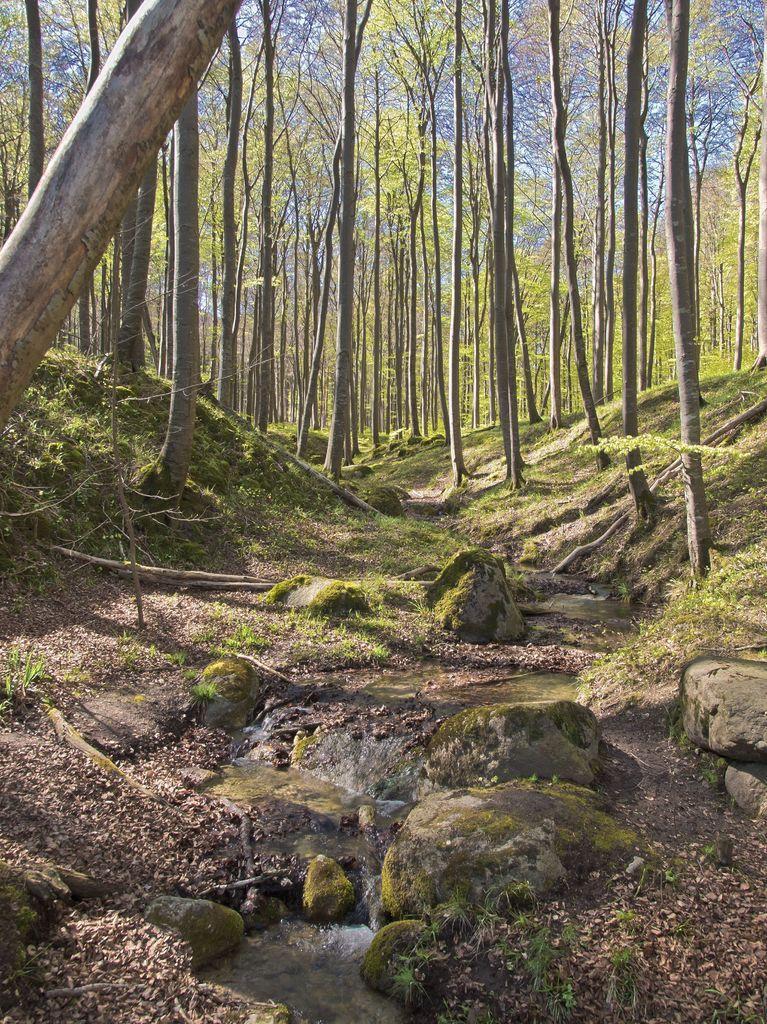Can you describe this image briefly? In this image, we can see many trees and at the bottom, there is water and we can see some rocks. 